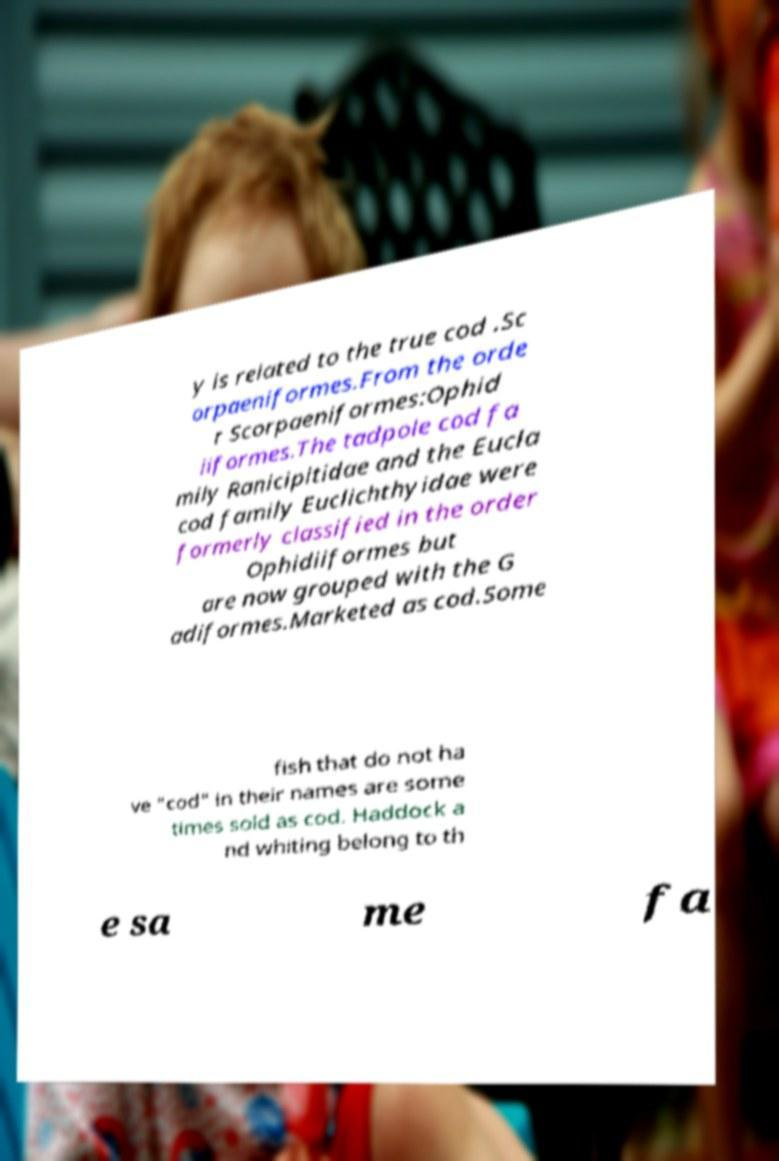Please read and relay the text visible in this image. What does it say? y is related to the true cod .Sc orpaeniformes.From the orde r Scorpaeniformes:Ophid iiformes.The tadpole cod fa mily Ranicipitidae and the Eucla cod family Euclichthyidae were formerly classified in the order Ophidiiformes but are now grouped with the G adiformes.Marketed as cod.Some fish that do not ha ve "cod" in their names are some times sold as cod. Haddock a nd whiting belong to th e sa me fa 